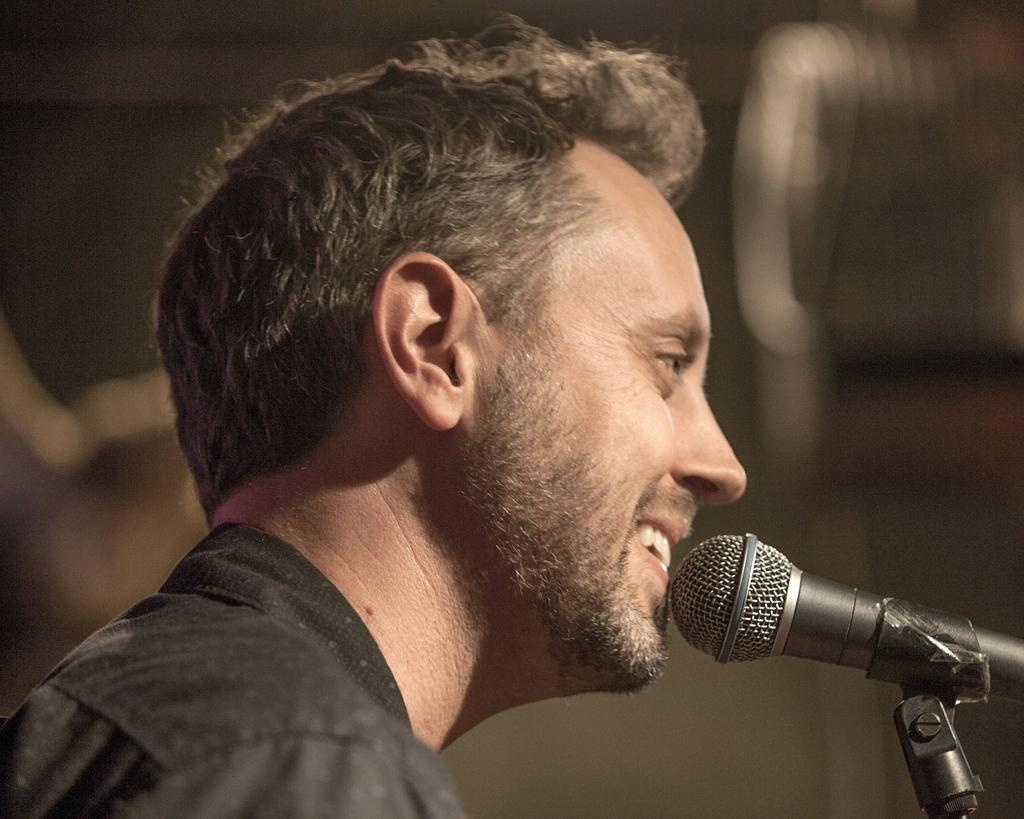Who is present in the image? There is a man in the image. What is the man doing in the image? The man is smiling in the image. What object can be seen near the man? There is a microphone in the image. What color are the frogs in the image? There are no frogs present in the image. How does the ocean look in the image? There is no ocean present in the image. 